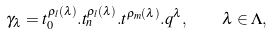<formula> <loc_0><loc_0><loc_500><loc_500>\gamma _ { \lambda } = t _ { 0 } ^ { \rho _ { l } ( \lambda ) } . t _ { n } ^ { \rho _ { l } ( \lambda ) } . t ^ { \rho _ { m } ( \lambda ) } . q ^ { \lambda } , \quad \lambda \in \Lambda ,</formula> 